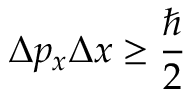Convert formula to latex. <formula><loc_0><loc_0><loc_500><loc_500>\Delta p _ { x } \Delta x \geq { \frac { } { 2 } }</formula> 